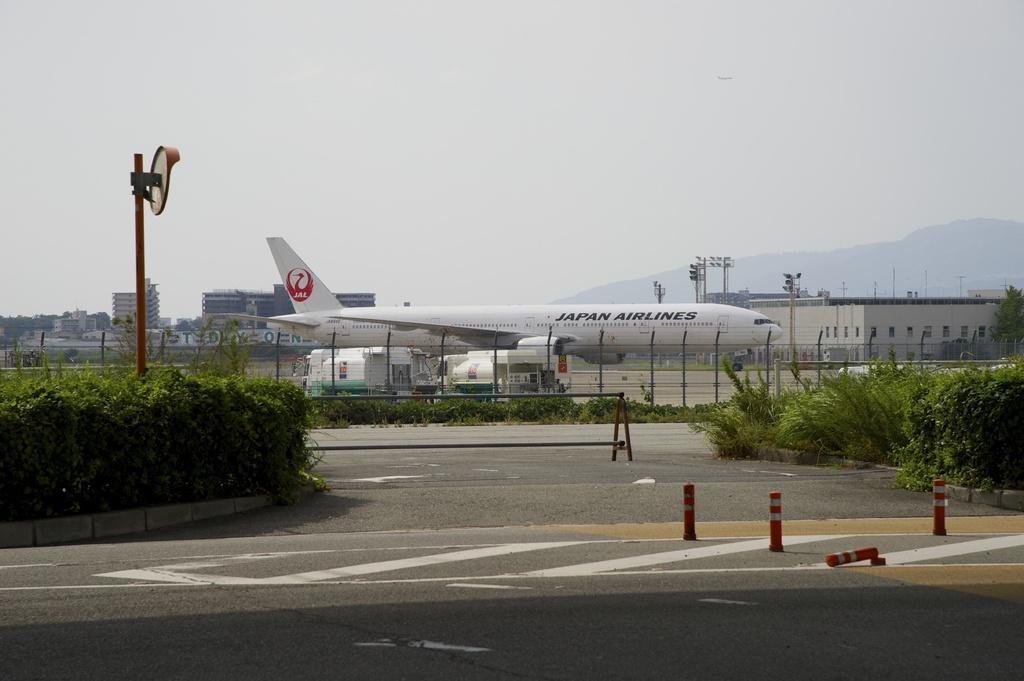Describe this image in one or two sentences. To the bottom of the image there is a road with zebra crossing and orange color objects. To the left side of the image there are plants. In the middle of the plants there is a red pole with the sign board. And to the right side of the image there are plants. In the middle of the road there is a stand. Behind the stand there is a fencing. Behind the fencing there are trees, flights and other items on it. In the background there are buildings trees and poles with traffic signals. To the top of the image there is a sky. 